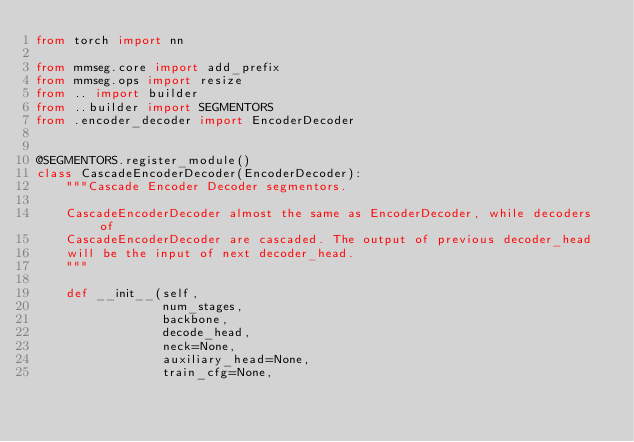Convert code to text. <code><loc_0><loc_0><loc_500><loc_500><_Python_>from torch import nn

from mmseg.core import add_prefix
from mmseg.ops import resize
from .. import builder
from ..builder import SEGMENTORS
from .encoder_decoder import EncoderDecoder


@SEGMENTORS.register_module()
class CascadeEncoderDecoder(EncoderDecoder):
    """Cascade Encoder Decoder segmentors.

    CascadeEncoderDecoder almost the same as EncoderDecoder, while decoders of
    CascadeEncoderDecoder are cascaded. The output of previous decoder_head
    will be the input of next decoder_head.
    """

    def __init__(self,
                 num_stages,
                 backbone,
                 decode_head,
                 neck=None,
                 auxiliary_head=None,
                 train_cfg=None,</code> 